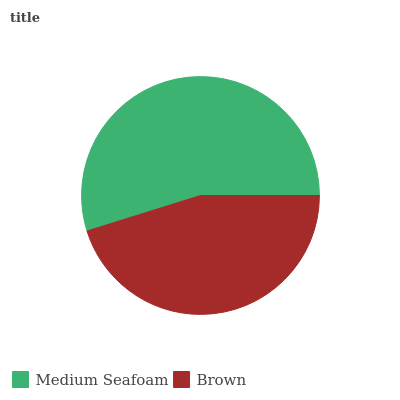Is Brown the minimum?
Answer yes or no. Yes. Is Medium Seafoam the maximum?
Answer yes or no. Yes. Is Brown the maximum?
Answer yes or no. No. Is Medium Seafoam greater than Brown?
Answer yes or no. Yes. Is Brown less than Medium Seafoam?
Answer yes or no. Yes. Is Brown greater than Medium Seafoam?
Answer yes or no. No. Is Medium Seafoam less than Brown?
Answer yes or no. No. Is Medium Seafoam the high median?
Answer yes or no. Yes. Is Brown the low median?
Answer yes or no. Yes. Is Brown the high median?
Answer yes or no. No. Is Medium Seafoam the low median?
Answer yes or no. No. 